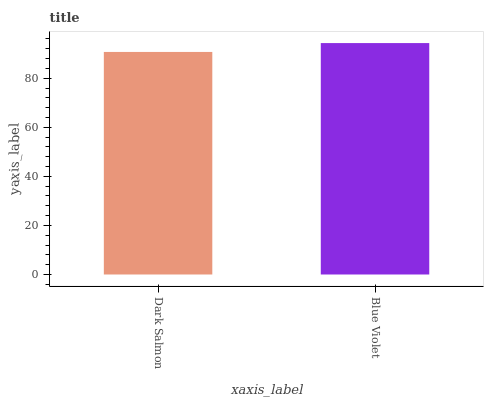Is Dark Salmon the minimum?
Answer yes or no. Yes. Is Blue Violet the maximum?
Answer yes or no. Yes. Is Blue Violet the minimum?
Answer yes or no. No. Is Blue Violet greater than Dark Salmon?
Answer yes or no. Yes. Is Dark Salmon less than Blue Violet?
Answer yes or no. Yes. Is Dark Salmon greater than Blue Violet?
Answer yes or no. No. Is Blue Violet less than Dark Salmon?
Answer yes or no. No. Is Blue Violet the high median?
Answer yes or no. Yes. Is Dark Salmon the low median?
Answer yes or no. Yes. Is Dark Salmon the high median?
Answer yes or no. No. Is Blue Violet the low median?
Answer yes or no. No. 